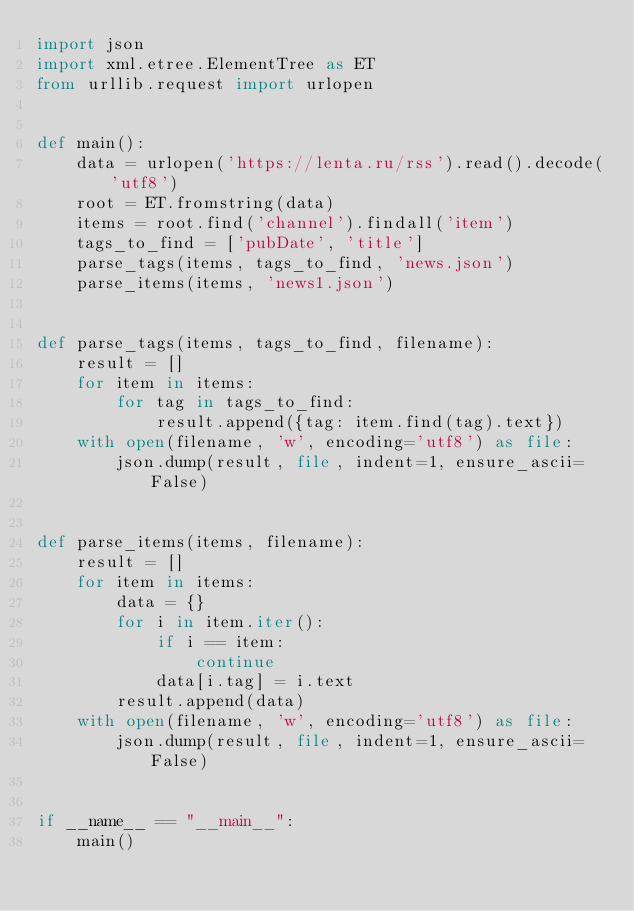<code> <loc_0><loc_0><loc_500><loc_500><_Python_>import json
import xml.etree.ElementTree as ET
from urllib.request import urlopen


def main():
    data = urlopen('https://lenta.ru/rss').read().decode('utf8')
    root = ET.fromstring(data)
    items = root.find('channel').findall('item')
    tags_to_find = ['pubDate', 'title']
    parse_tags(items, tags_to_find, 'news.json')
    parse_items(items, 'news1.json')


def parse_tags(items, tags_to_find, filename):
    result = []
    for item in items:
        for tag in tags_to_find:
            result.append({tag: item.find(tag).text})
    with open(filename, 'w', encoding='utf8') as file:
        json.dump(result, file, indent=1, ensure_ascii=False)


def parse_items(items, filename):
    result = []
    for item in items:
        data = {}
        for i in item.iter():
            if i == item:
                continue
            data[i.tag] = i.text
        result.append(data)
    with open(filename, 'w', encoding='utf8') as file:
        json.dump(result, file, indent=1, ensure_ascii=False)


if __name__ == "__main__":
    main()
</code> 